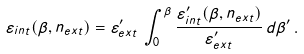<formula> <loc_0><loc_0><loc_500><loc_500>\varepsilon _ { i n t } ( \beta , n _ { e x t } ) = \varepsilon ^ { \prime } _ { e x t } \, \int _ { 0 } ^ { \beta } \frac { \varepsilon ^ { \prime } _ { i n t } ( \beta , n _ { e x t } ) } { \varepsilon ^ { \prime } _ { e x t } } \, d \beta ^ { \prime } \, .</formula> 